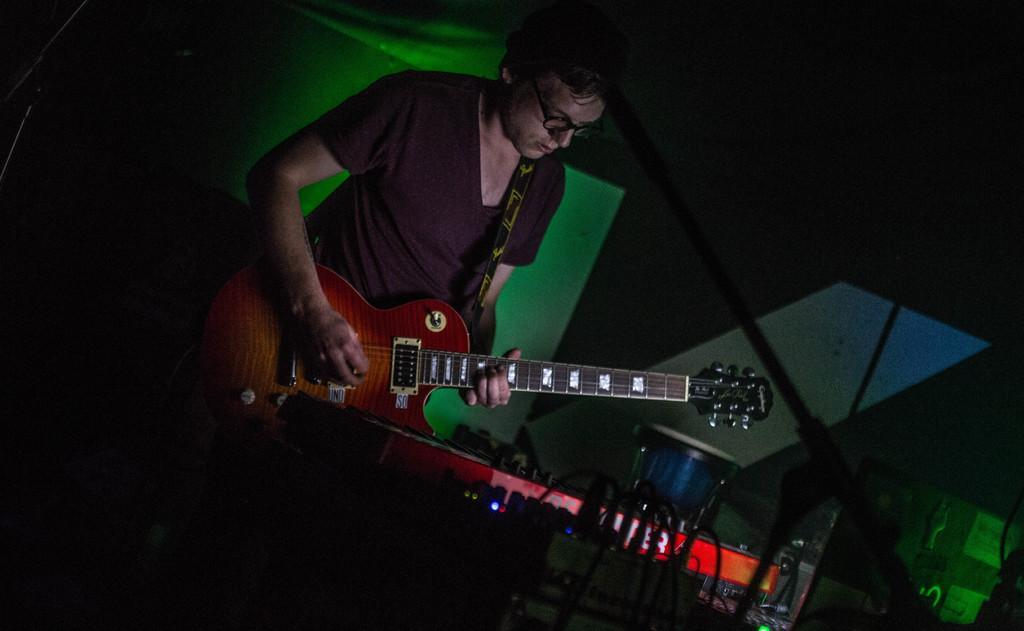How would you summarize this image in a sentence or two? In the image we can see there is a man who is holding a guitar and in front of him there is a casio. 